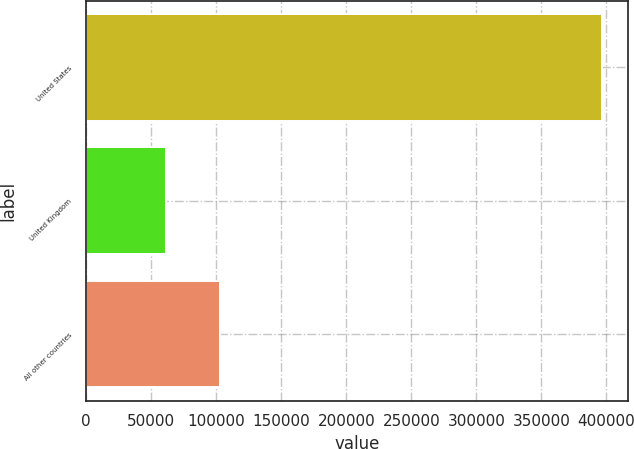Convert chart. <chart><loc_0><loc_0><loc_500><loc_500><bar_chart><fcel>United States<fcel>United Kingdom<fcel>All other countries<nl><fcel>396608<fcel>61327<fcel>102821<nl></chart> 